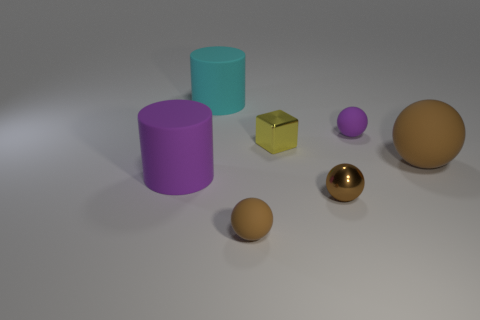Subtract all brown balls. How many were subtracted if there are1brown balls left? 2 Subtract all tiny purple matte spheres. How many spheres are left? 3 Add 2 tiny red spheres. How many objects exist? 9 Subtract all cyan cylinders. How many cylinders are left? 1 Add 2 big blue objects. How many big blue objects exist? 2 Subtract 1 purple balls. How many objects are left? 6 Subtract all cylinders. How many objects are left? 5 Subtract all gray cubes. Subtract all gray cylinders. How many cubes are left? 1 Subtract all brown spheres. How many purple cylinders are left? 1 Subtract all purple cubes. Subtract all large matte spheres. How many objects are left? 6 